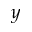<formula> <loc_0><loc_0><loc_500><loc_500>y</formula> 